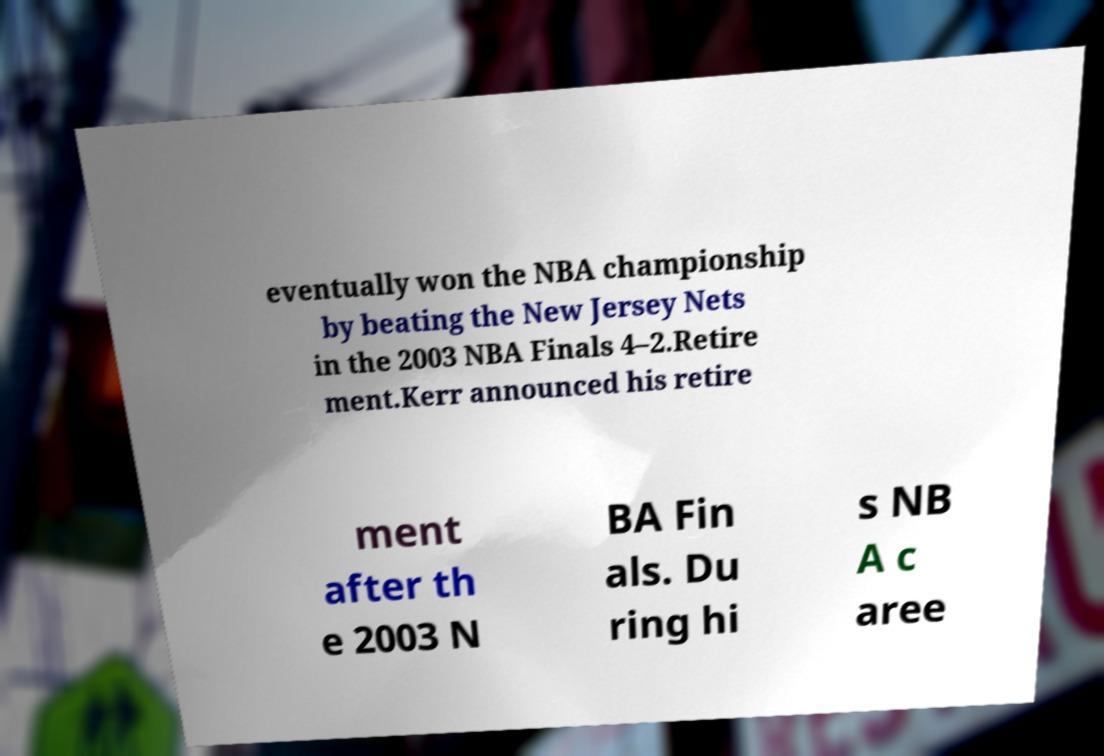Please read and relay the text visible in this image. What does it say? eventually won the NBA championship by beating the New Jersey Nets in the 2003 NBA Finals 4–2.Retire ment.Kerr announced his retire ment after th e 2003 N BA Fin als. Du ring hi s NB A c aree 